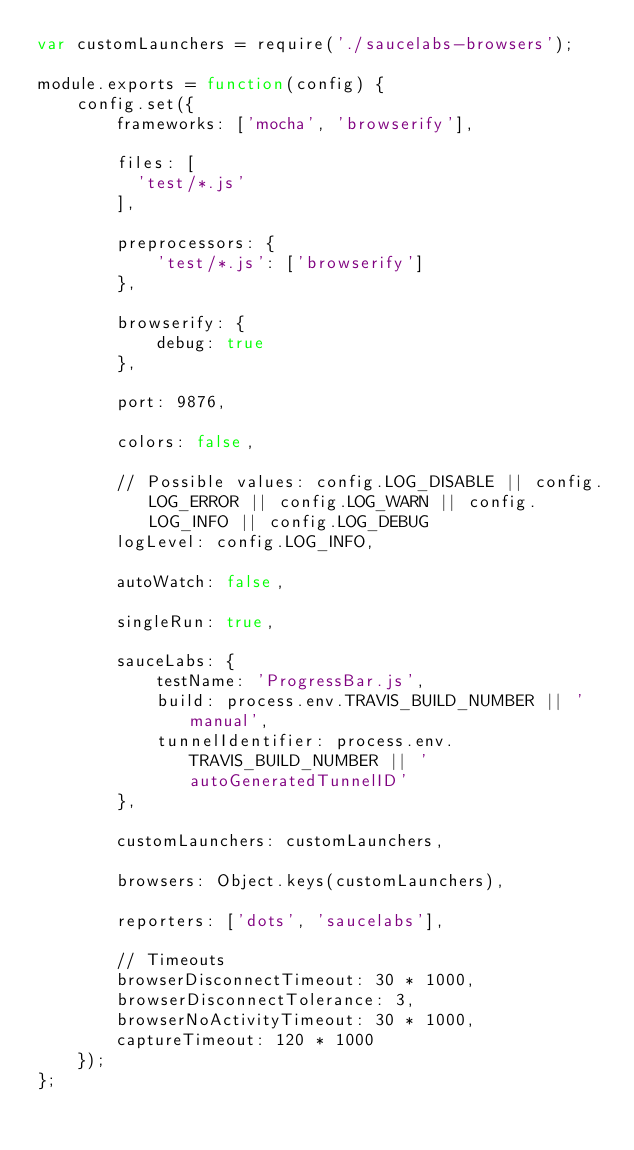<code> <loc_0><loc_0><loc_500><loc_500><_JavaScript_>var customLaunchers = require('./saucelabs-browsers');

module.exports = function(config) {
    config.set({
        frameworks: ['mocha', 'browserify'],

        files: [
          'test/*.js'
        ],

        preprocessors: {
            'test/*.js': ['browserify']
        },

        browserify: {
            debug: true
        },

        port: 9876,

        colors: false,

        // Possible values: config.LOG_DISABLE || config.LOG_ERROR || config.LOG_WARN || config.LOG_INFO || config.LOG_DEBUG
        logLevel: config.LOG_INFO,

        autoWatch: false,

        singleRun: true,

        sauceLabs: {
            testName: 'ProgressBar.js',
            build: process.env.TRAVIS_BUILD_NUMBER || 'manual',
            tunnelIdentifier: process.env.TRAVIS_BUILD_NUMBER || 'autoGeneratedTunnelID'
        },

        customLaunchers: customLaunchers,

        browsers: Object.keys(customLaunchers),

        reporters: ['dots', 'saucelabs'],

        // Timeouts
        browserDisconnectTimeout: 30 * 1000,
        browserDisconnectTolerance: 3,
        browserNoActivityTimeout: 30 * 1000,
        captureTimeout: 120 * 1000
    });
};
</code> 